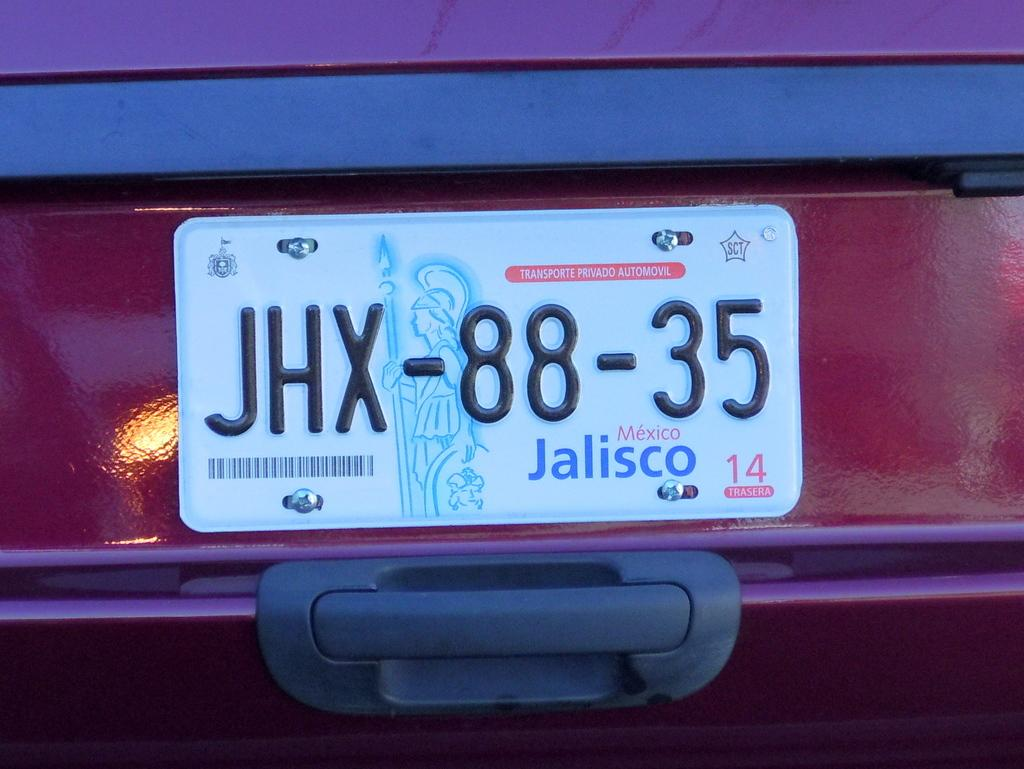<image>
Describe the image concisely. A Mexican license plate with a picture of a roman soldier. 